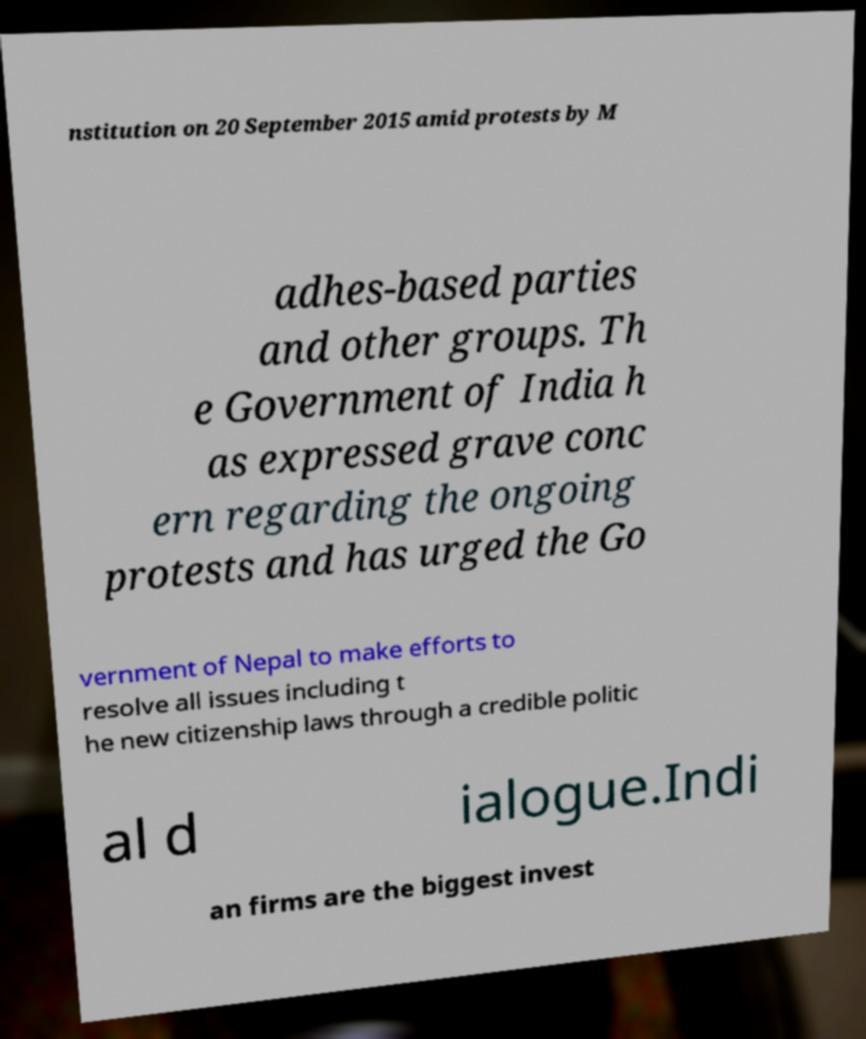Please read and relay the text visible in this image. What does it say? nstitution on 20 September 2015 amid protests by M adhes-based parties and other groups. Th e Government of India h as expressed grave conc ern regarding the ongoing protests and has urged the Go vernment of Nepal to make efforts to resolve all issues including t he new citizenship laws through a credible politic al d ialogue.Indi an firms are the biggest invest 